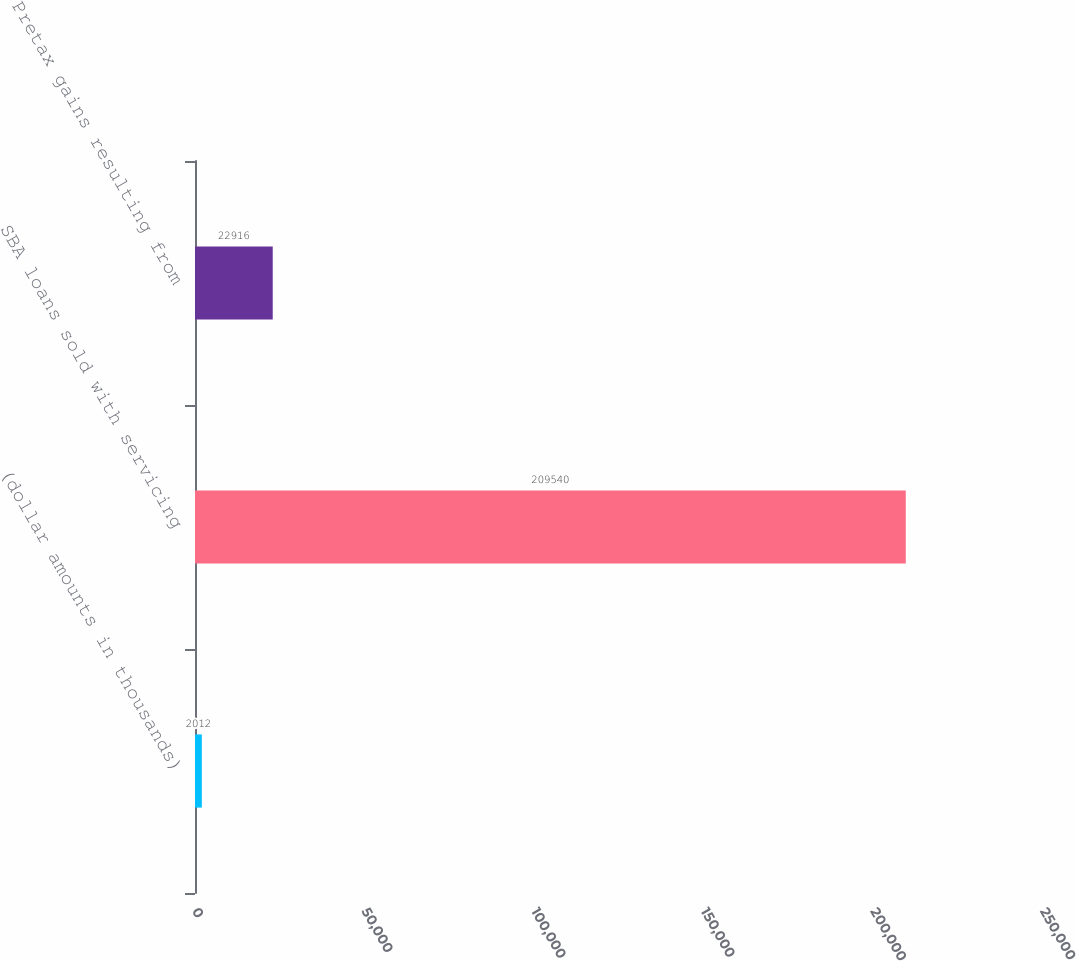<chart> <loc_0><loc_0><loc_500><loc_500><bar_chart><fcel>(dollar amounts in thousands)<fcel>SBA loans sold with servicing<fcel>Pretax gains resulting from<nl><fcel>2012<fcel>209540<fcel>22916<nl></chart> 